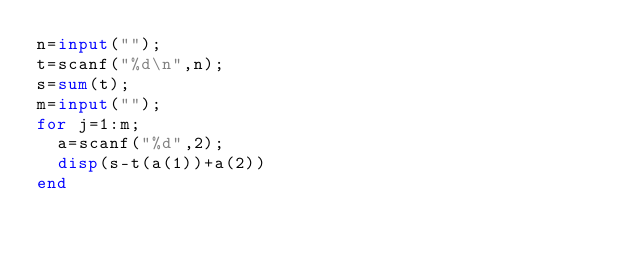<code> <loc_0><loc_0><loc_500><loc_500><_Octave_>n=input("");
t=scanf("%d\n",n);
s=sum(t);
m=input("");
for j=1:m;
	a=scanf("%d",2);
	disp(s-t(a(1))+a(2))
end
</code> 